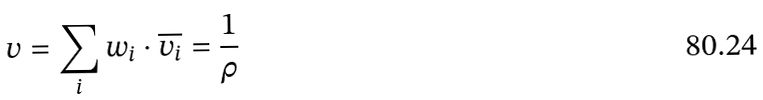<formula> <loc_0><loc_0><loc_500><loc_500>v = \sum _ { i } w _ { i } \cdot \overline { v _ { i } } = \frac { 1 } { \rho }</formula> 